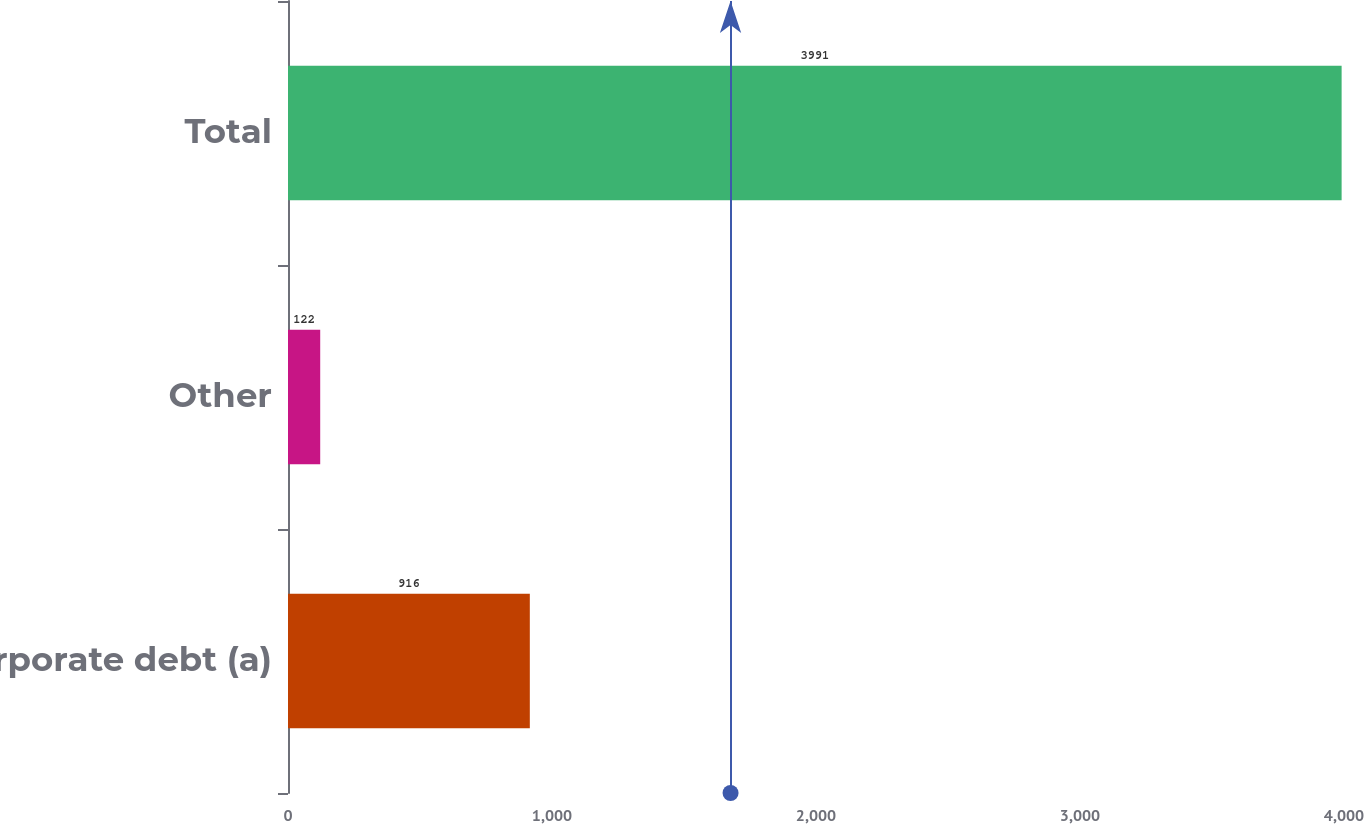Convert chart to OTSL. <chart><loc_0><loc_0><loc_500><loc_500><bar_chart><fcel>Corporate debt (a)<fcel>Other<fcel>Total<nl><fcel>916<fcel>122<fcel>3991<nl></chart> 